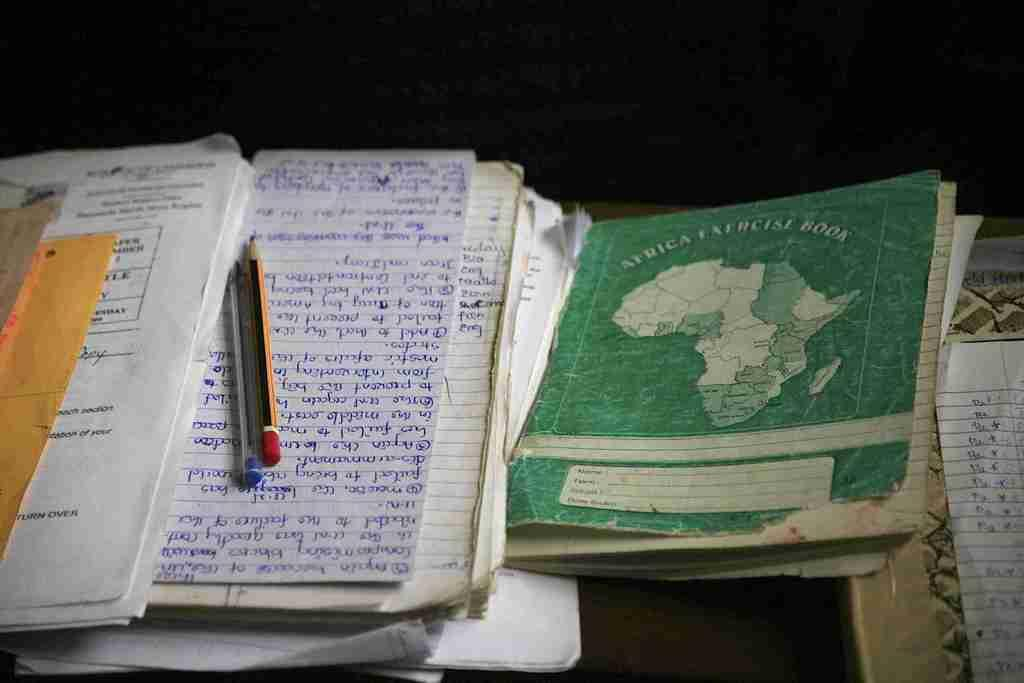<image>
Provide a brief description of the given image. a green Africa Exercise Book next to other paper 